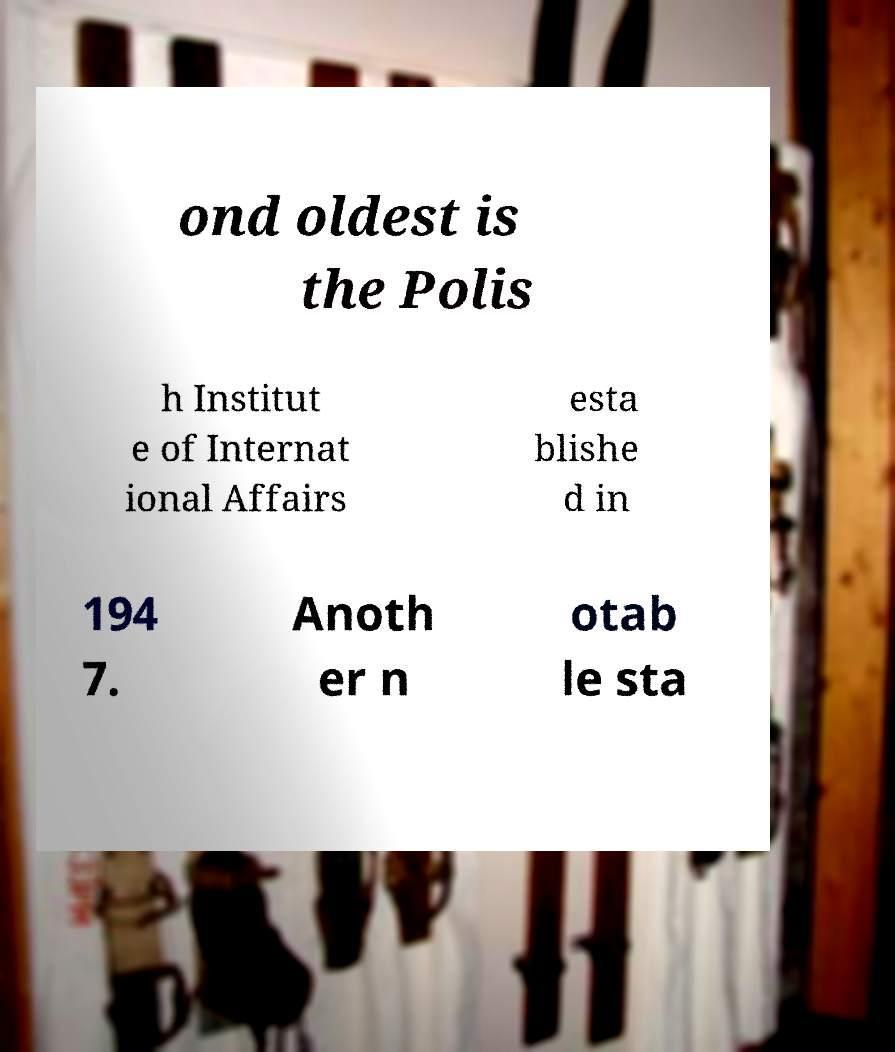For documentation purposes, I need the text within this image transcribed. Could you provide that? ond oldest is the Polis h Institut e of Internat ional Affairs esta blishe d in 194 7. Anoth er n otab le sta 